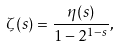Convert formula to latex. <formula><loc_0><loc_0><loc_500><loc_500>\zeta ( s ) = { \frac { \eta ( s ) } { 1 - 2 ^ { 1 - s } } } ,</formula> 